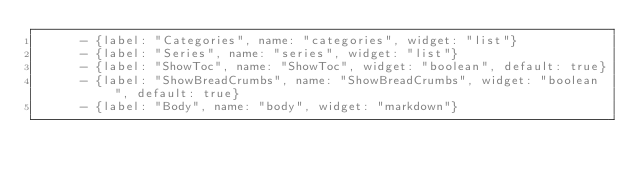<code> <loc_0><loc_0><loc_500><loc_500><_YAML_>      - {label: "Categories", name: "categories", widget: "list"}
      - {label: "Series", name: "series", widget: "list"}
      - {label: "ShowToc", name: "ShowToc", widget: "boolean", default: true}
      - {label: "ShowBreadCrumbs", name: "ShowBreadCrumbs", widget: "boolean", default: true}
      - {label: "Body", name: "body", widget: "markdown"}
</code> 